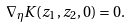Convert formula to latex. <formula><loc_0><loc_0><loc_500><loc_500>\nabla _ { \eta } K ( z _ { 1 } , z _ { 2 } , 0 ) = 0 .</formula> 